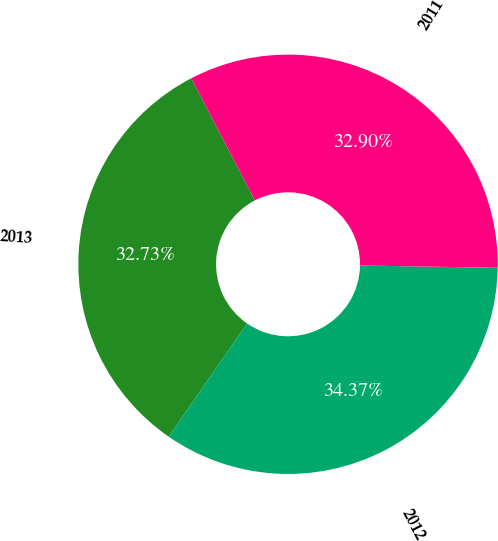Convert chart. <chart><loc_0><loc_0><loc_500><loc_500><pie_chart><fcel>2013<fcel>2012<fcel>2011<nl><fcel>32.73%<fcel>34.37%<fcel>32.9%<nl></chart> 